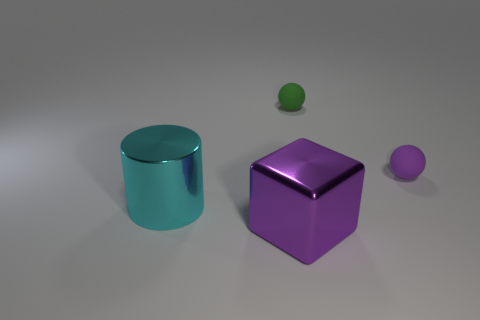What size is the matte object that is the same color as the large block?
Ensure brevity in your answer.  Small. What is the shape of the thing that is the same color as the block?
Provide a succinct answer. Sphere. Are any tiny green balls visible?
Offer a terse response. Yes. There is a shiny object that is to the right of the cyan object; does it have the same shape as the large metallic object to the left of the purple block?
Keep it short and to the point. No. What number of large objects are either purple things or purple matte things?
Provide a succinct answer. 1. What shape is the thing that is made of the same material as the big cyan cylinder?
Offer a terse response. Cube. Does the green matte object have the same shape as the large purple metal thing?
Ensure brevity in your answer.  No. The block is what color?
Provide a succinct answer. Purple. What number of objects are either tiny green objects or brown shiny blocks?
Offer a very short reply. 1. Is there any other thing that has the same material as the cyan thing?
Ensure brevity in your answer.  Yes. 